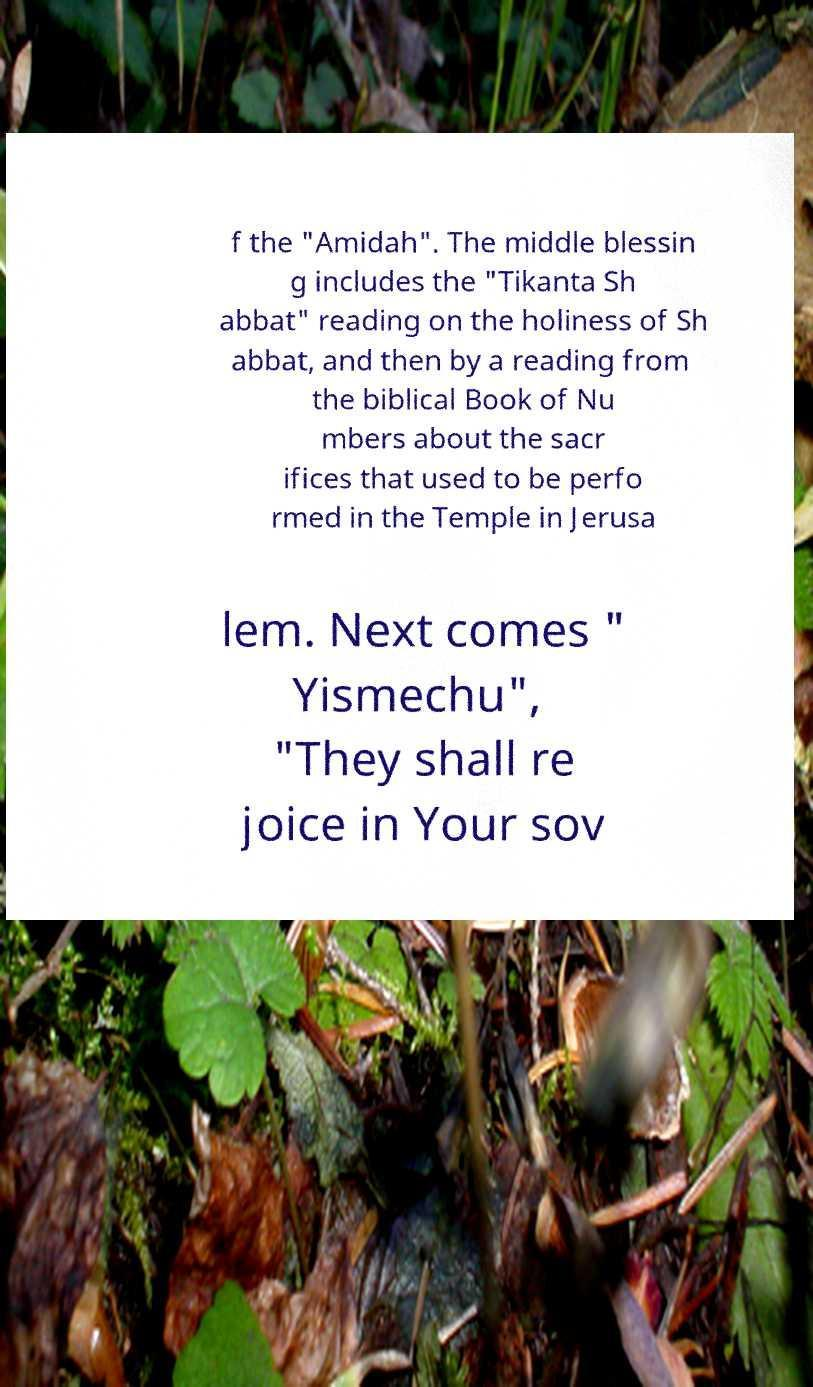Could you assist in decoding the text presented in this image and type it out clearly? f the "Amidah". The middle blessin g includes the "Tikanta Sh abbat" reading on the holiness of Sh abbat, and then by a reading from the biblical Book of Nu mbers about the sacr ifices that used to be perfo rmed in the Temple in Jerusa lem. Next comes " Yismechu", "They shall re joice in Your sov 